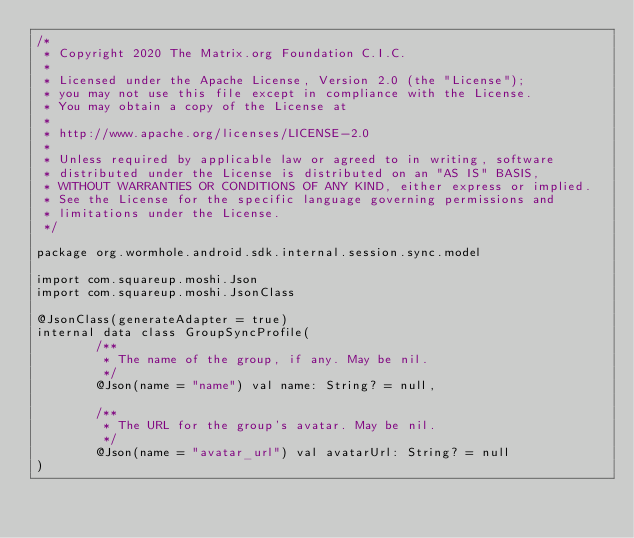Convert code to text. <code><loc_0><loc_0><loc_500><loc_500><_Kotlin_>/*
 * Copyright 2020 The Matrix.org Foundation C.I.C.
 *
 * Licensed under the Apache License, Version 2.0 (the "License");
 * you may not use this file except in compliance with the License.
 * You may obtain a copy of the License at
 *
 * http://www.apache.org/licenses/LICENSE-2.0
 *
 * Unless required by applicable law or agreed to in writing, software
 * distributed under the License is distributed on an "AS IS" BASIS,
 * WITHOUT WARRANTIES OR CONDITIONS OF ANY KIND, either express or implied.
 * See the License for the specific language governing permissions and
 * limitations under the License.
 */

package org.wormhole.android.sdk.internal.session.sync.model

import com.squareup.moshi.Json
import com.squareup.moshi.JsonClass

@JsonClass(generateAdapter = true)
internal data class GroupSyncProfile(
        /**
         * The name of the group, if any. May be nil.
         */
        @Json(name = "name") val name: String? = null,

        /**
         * The URL for the group's avatar. May be nil.
         */
        @Json(name = "avatar_url") val avatarUrl: String? = null
)
</code> 